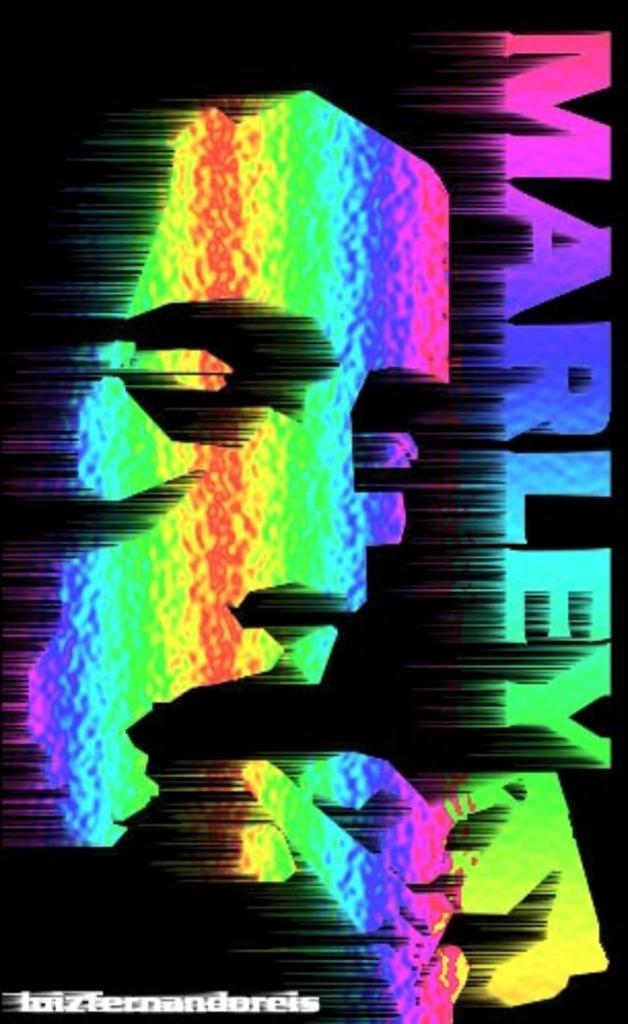Could you give a brief overview of what you see in this image? This is an animated image with some text and image on it. 